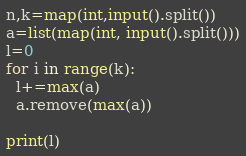<code> <loc_0><loc_0><loc_500><loc_500><_Python_>n,k=map(int,input().split())
a=list(map(int, input().split()))
l=0
for i in range(k):
  l+=max(a)
  a.remove(max(a))

print(l)</code> 